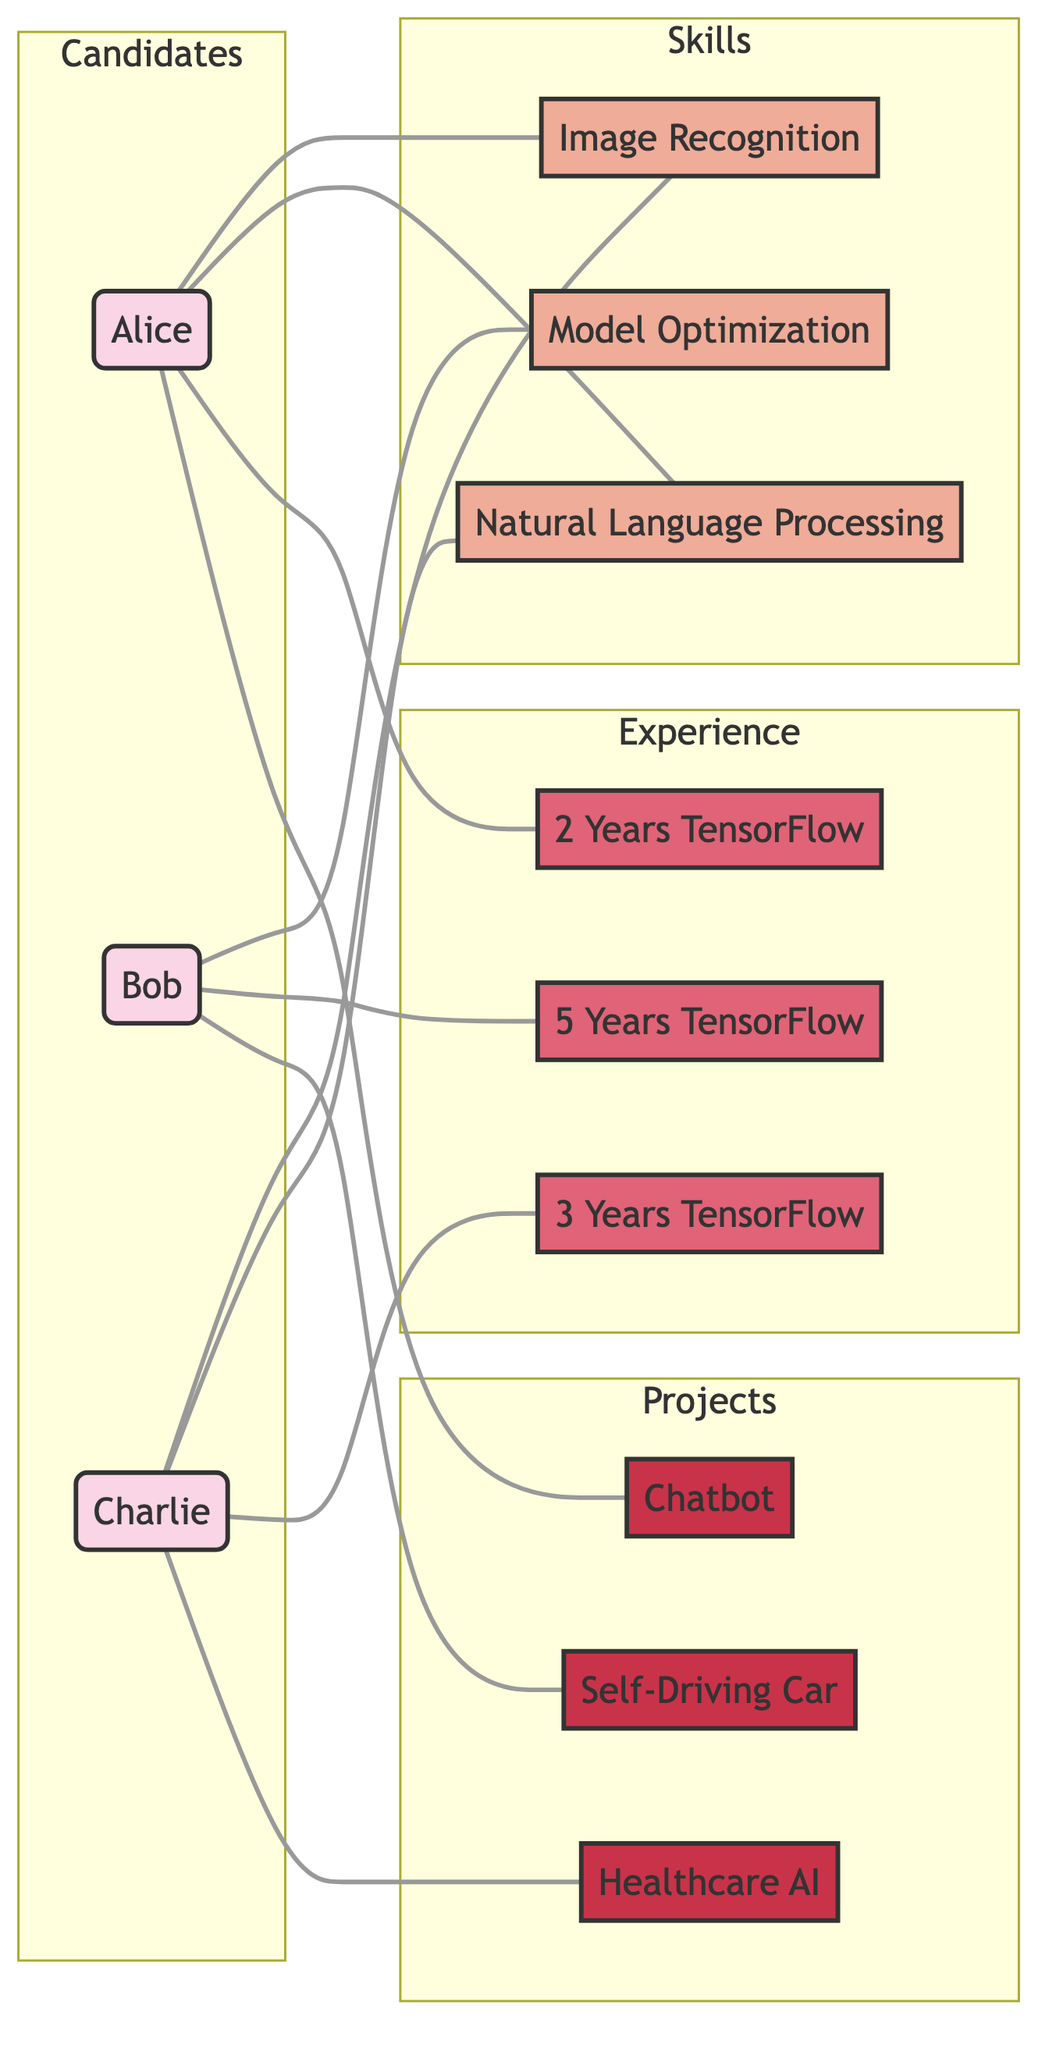What skills does Alice have? The diagram shows that Alice is connected to the skills of Image Recognition and Natural Language Processing. These are the skills represented by nodes that are directly linked to her node.
Answer: Image Recognition, Natural Language Processing How many years of TensorFlow experience does Bob have? Looking at Bob's connections, he is linked to the "5 Years Experience in TensorFlow" node, indicating he possesses that level of experience.
Answer: 5 Years Experience in TensorFlow Which projects is Charlie involved in? The diagram shows Charlie is connected to the Healthcare AI Project, indicating his involvement in that particular project as represented by the link to that node.
Answer: Healthcare AI Project How many candidates have experience in TensorFlow? The nodes linked to experience show that Alice, Bob, and Charlie are all connected to various levels of TensorFlow experience, suggesting three candidates possess this experience.
Answer: 3 What skill is linked to both Alice and Charlie? Both Alice and Charlie are connected to the Image Recognition skill, illustrating a commonality in their skill set as indicated by the shared connection to that node.
Answer: Image Recognition Which candidate has the most diverse skills? Analyzing the connections, Alice has links to two skills and one project, while Bob has one skill, one project, and Charlie has two skills and one project. Thus, Alice has the most diverse skill representation with four total links.
Answer: Alice What is the total number of projects represented in the diagram? The diagram includes links to three distinct projects: Self-Driving Car Project, Chatbot Development Project, and Healthcare AI Project, which are all represented by unique nodes.
Answer: 3 Which skill is exclusively linked to Bob? Bob is uniquely connected to the Model Optimization skill, as he is the only candidate with a link to that particular skill node, indicating it is not shared with other candidates.
Answer: Model Optimization What is the relationship between Alice and the Chatbot Development Project? The diagram illustrates a direct link between Alice and the Chatbot Development Project, indicating her involvement in that specific project.
Answer: Involvement 